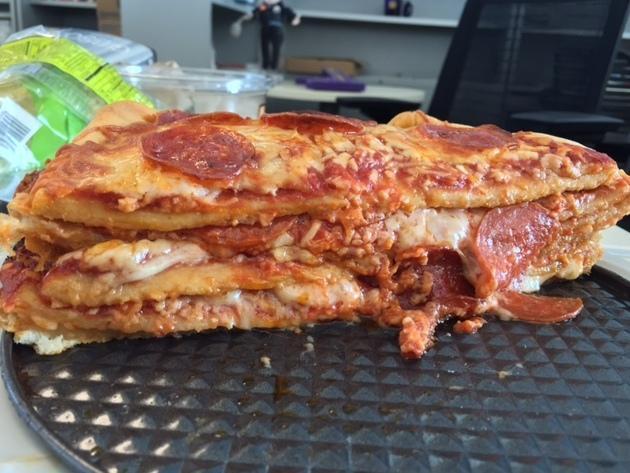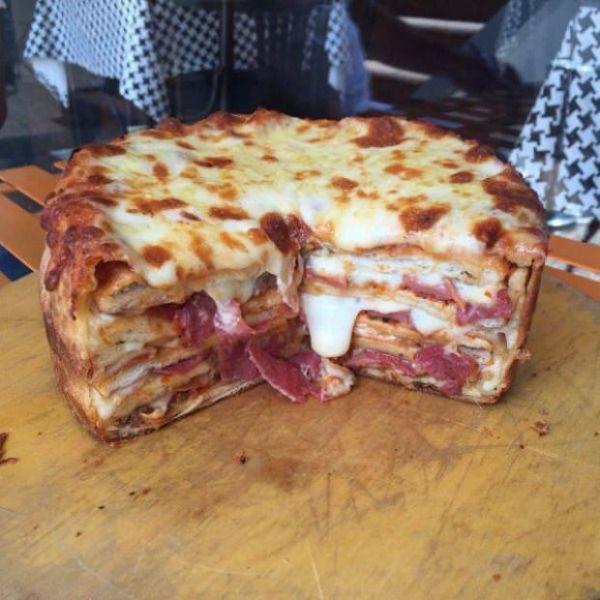The first image is the image on the left, the second image is the image on the right. Given the left and right images, does the statement "The right image shows one slice missing from a stuffed pizza, and the left image features at least one sliced pizza with no slices missing." hold true? Answer yes or no. No. The first image is the image on the left, the second image is the image on the right. Analyze the images presented: Is the assertion "There are three layers of pizza with at least one slice removed from the pie." valid? Answer yes or no. Yes. 